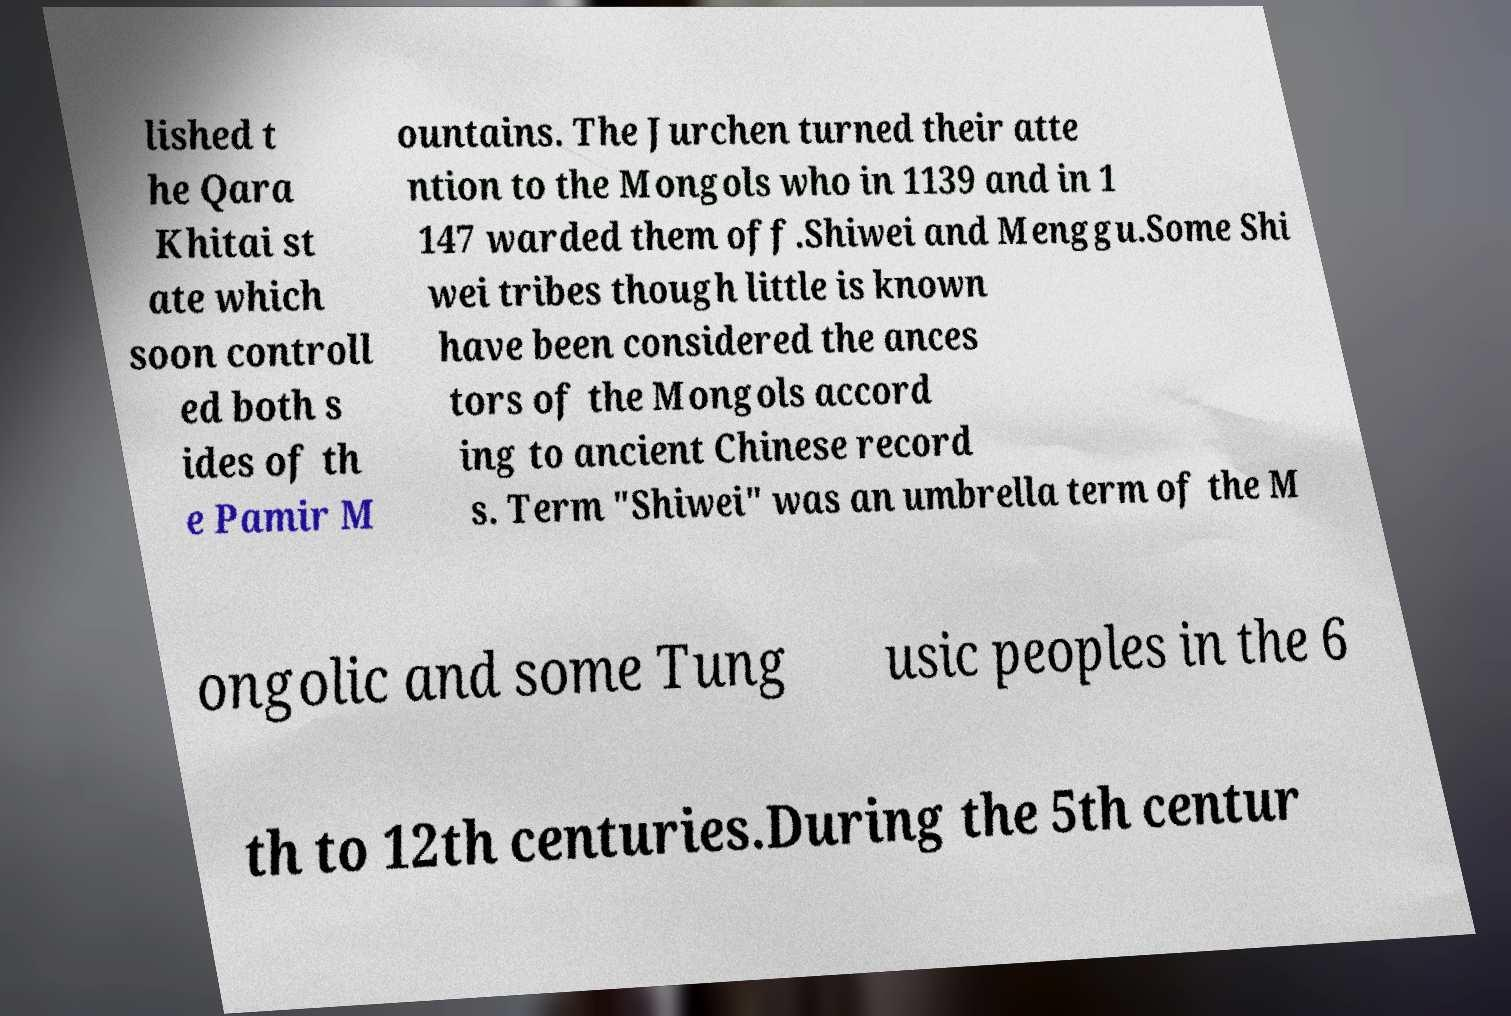Can you accurately transcribe the text from the provided image for me? lished t he Qara Khitai st ate which soon controll ed both s ides of th e Pamir M ountains. The Jurchen turned their atte ntion to the Mongols who in 1139 and in 1 147 warded them off.Shiwei and Menggu.Some Shi wei tribes though little is known have been considered the ances tors of the Mongols accord ing to ancient Chinese record s. Term "Shiwei" was an umbrella term of the M ongolic and some Tung usic peoples in the 6 th to 12th centuries.During the 5th centur 